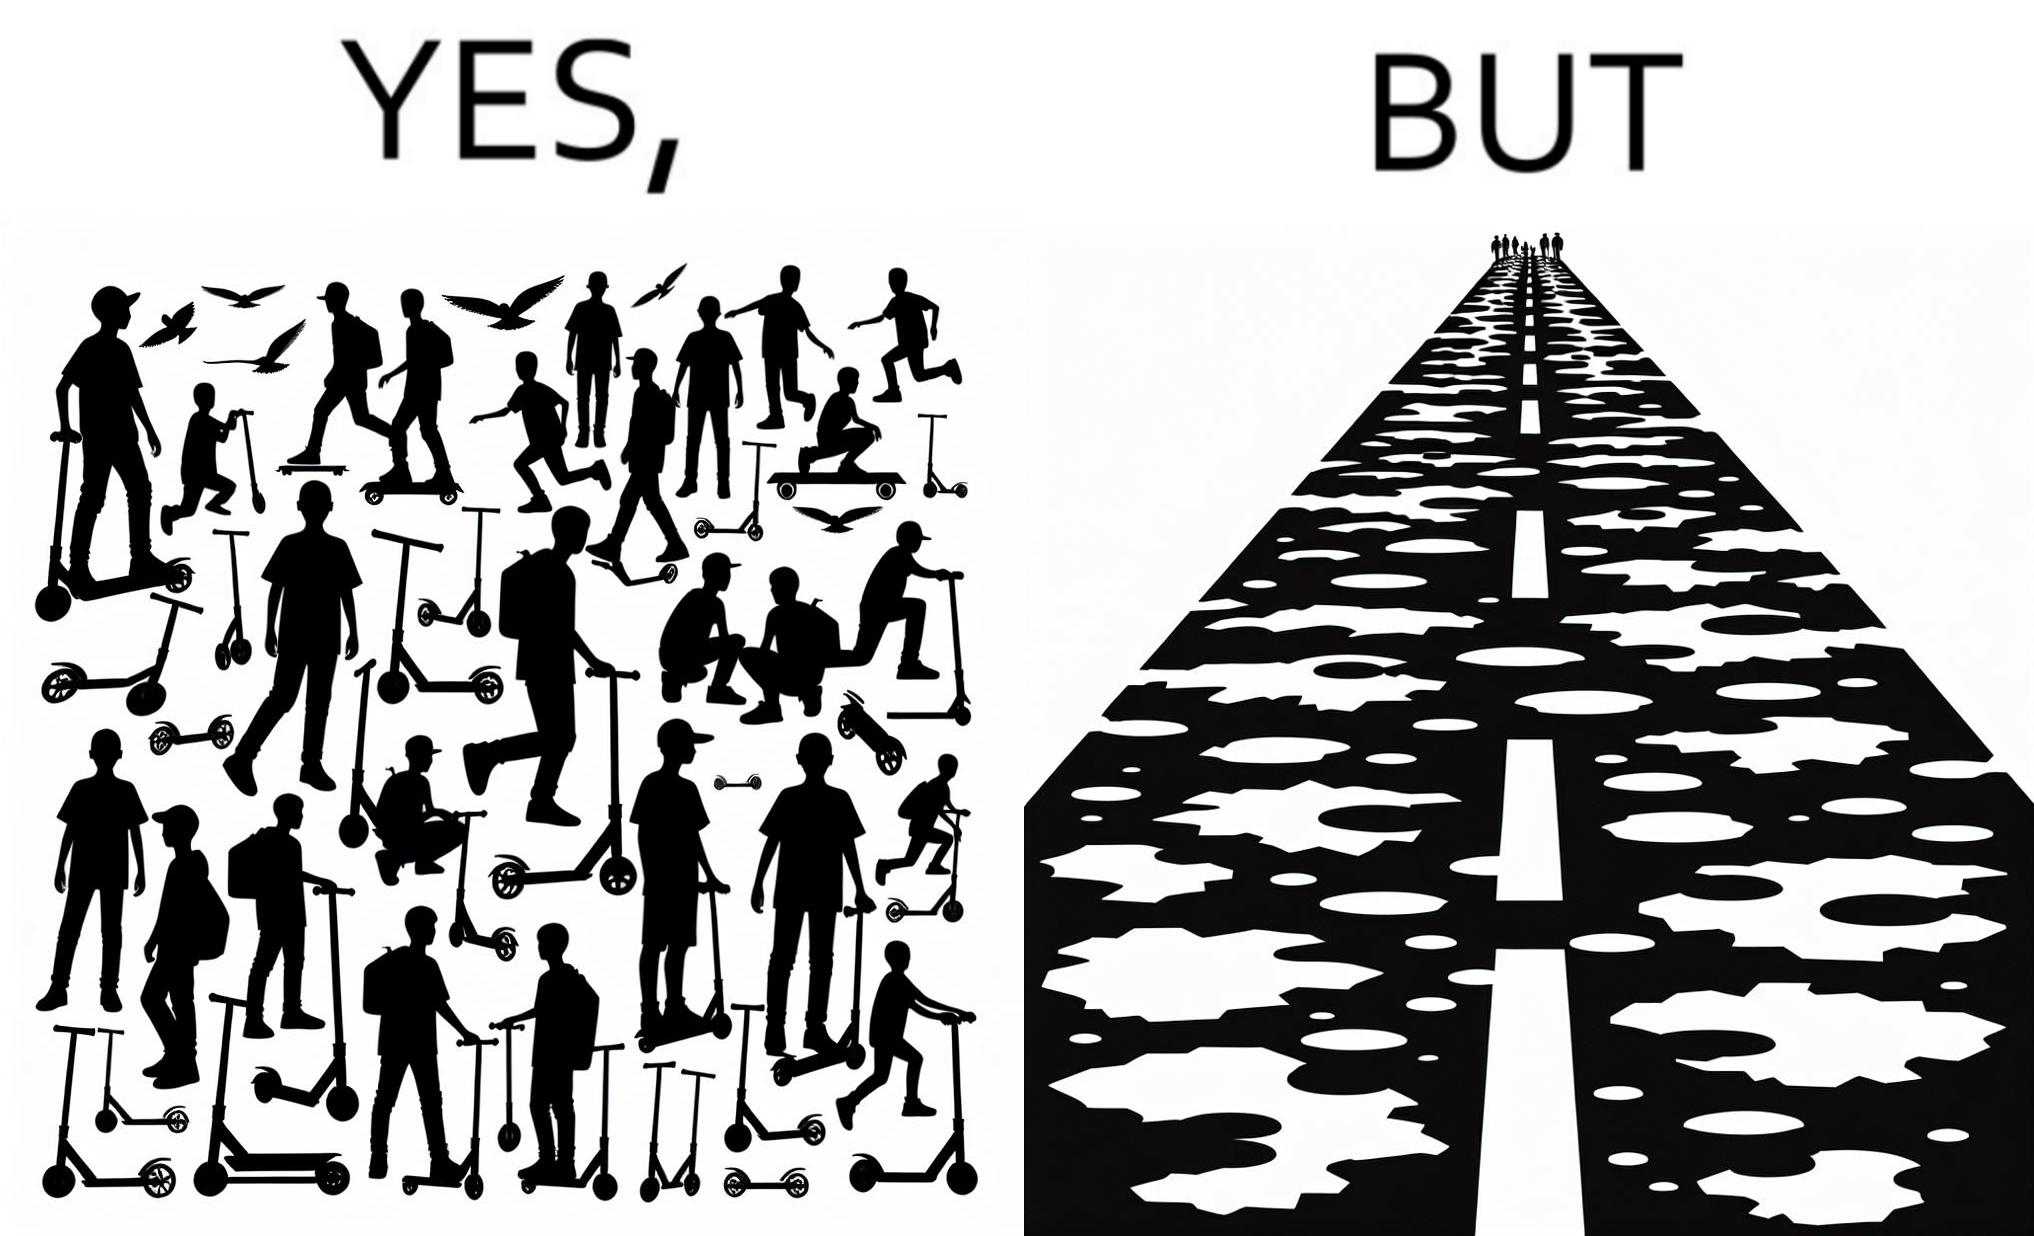What does this image depict? The image is ironic, because even after when the skateboard scooters are available for someone to ride but the road has many potholes that it is not suitable to ride the scooters on such roads 